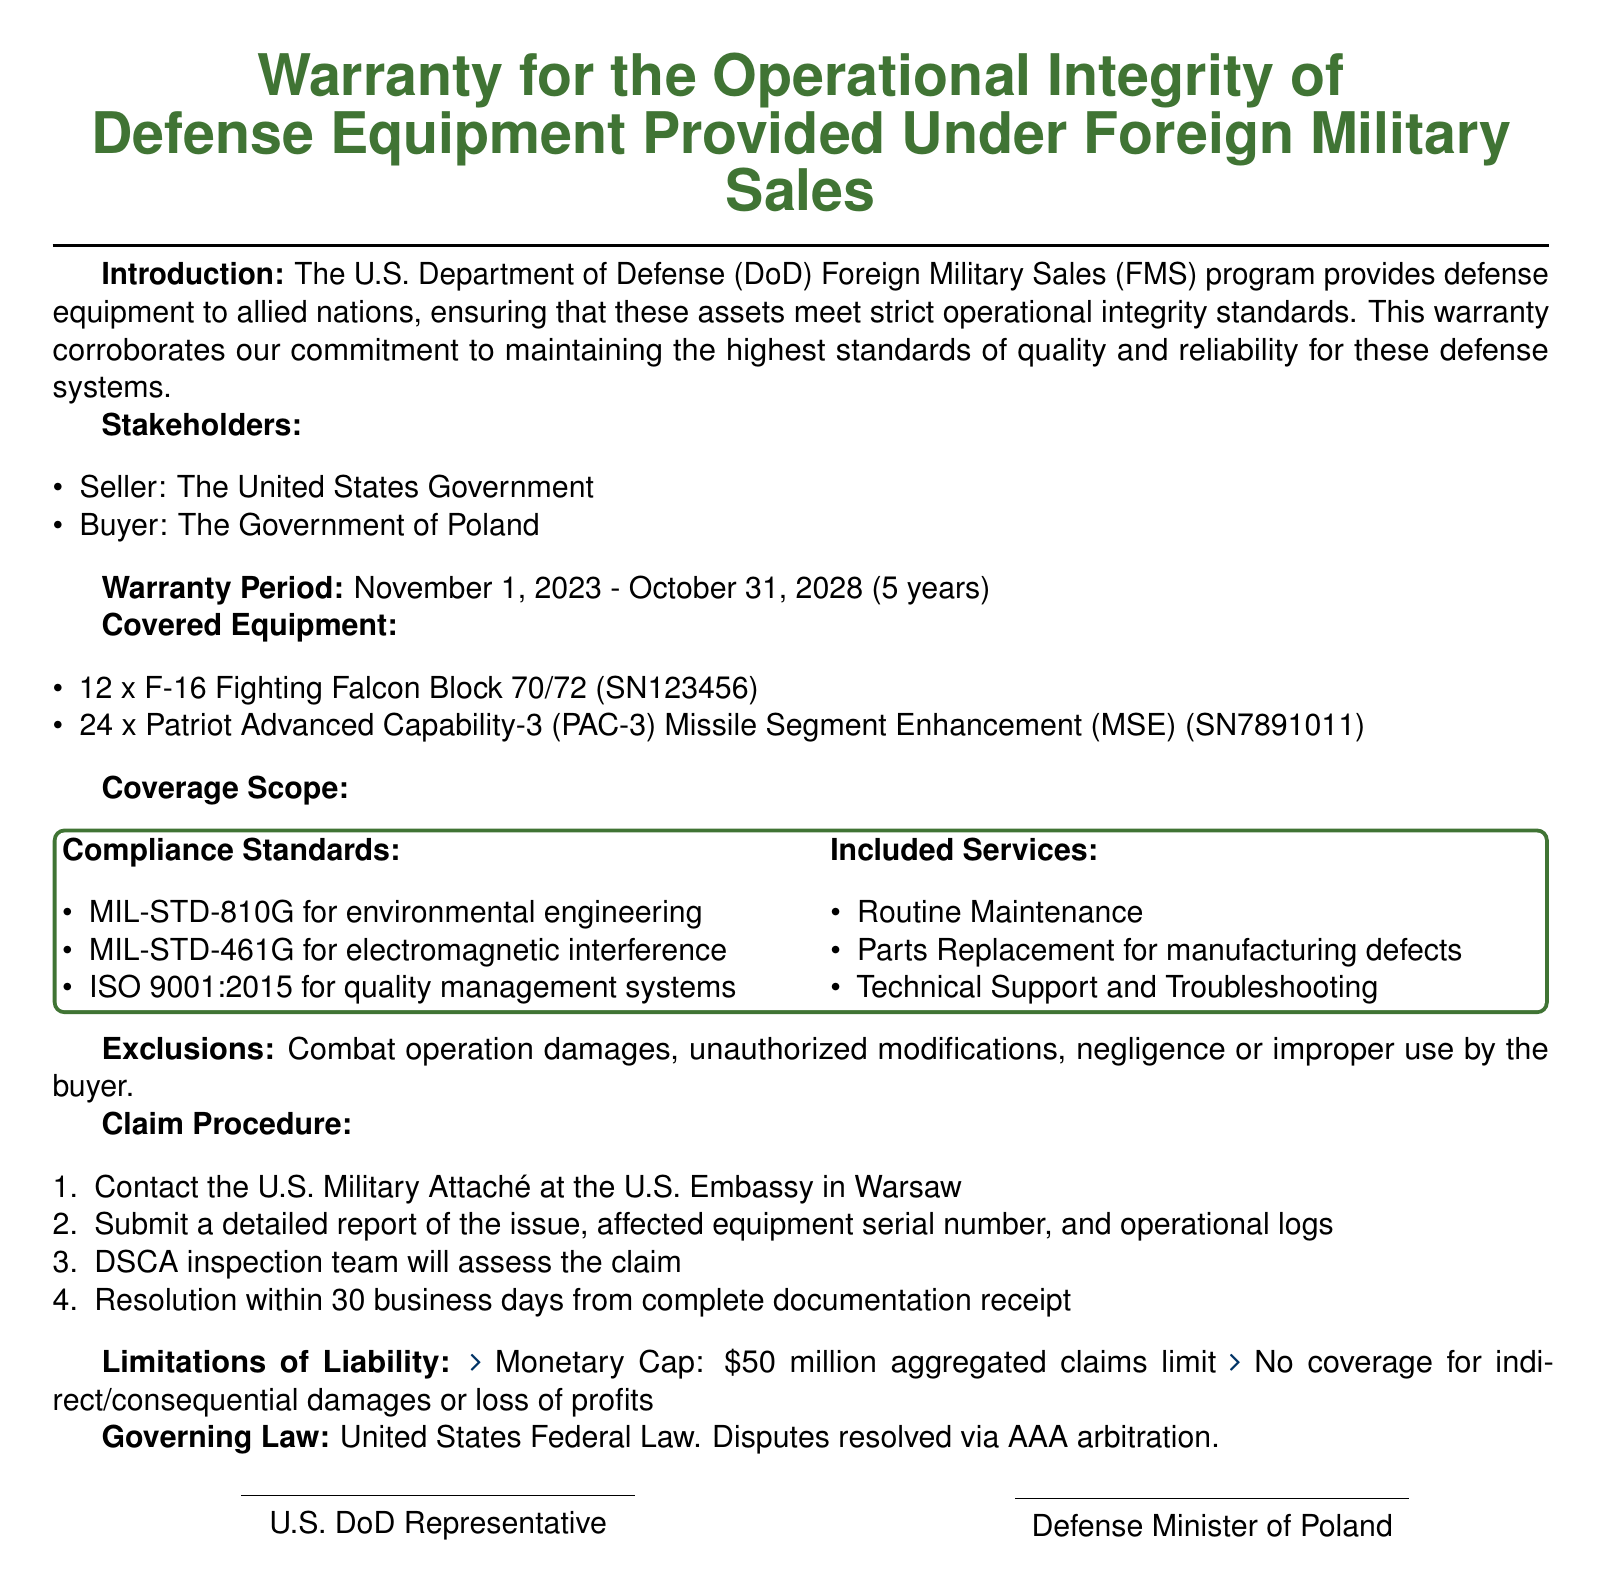what is the warranty period? The warranty period is specifically stated in the document, encompassing November 1, 2023, to October 31, 2028.
Answer: November 1, 2023 - October 31, 2028 who is the seller? The document identifies the seller as the United States Government.
Answer: The United States Government how many F-16 Fighting Falcons are covered? The document lists the number of F-16 Fighting Falcon Block 70/72 as 12.
Answer: 12 what is the monetary cap for claims? The limits of liability section outlines the monetary cap on claims as stated in the document.
Answer: 50 million what services are included in the warranty? The document specifies several services included, allowing for easy retrieval of this information.
Answer: Routine Maintenance, Parts Replacement for manufacturing defects, Technical Support and Troubleshooting what is the claim resolution time? The document mentions the time frame for resolution once complete documentation is received.
Answer: 30 business days what damages are excluded from coverage? The exclusions section lists specific types of damages that are not covered under the warranty.
Answer: Combat operation damages, unauthorized modifications, negligence or improper use by the buyer which standards must be complied with? The compliance standards section of the document lists the required standards explicitly.
Answer: MIL-STD-810G, MIL-STD-461G, ISO 9001:2015 how many Patriot missiles are included in the warranty? The covered equipment section clearly specifies the number of Patriot Advanced Capability-3 missiles covered.
Answer: 24 